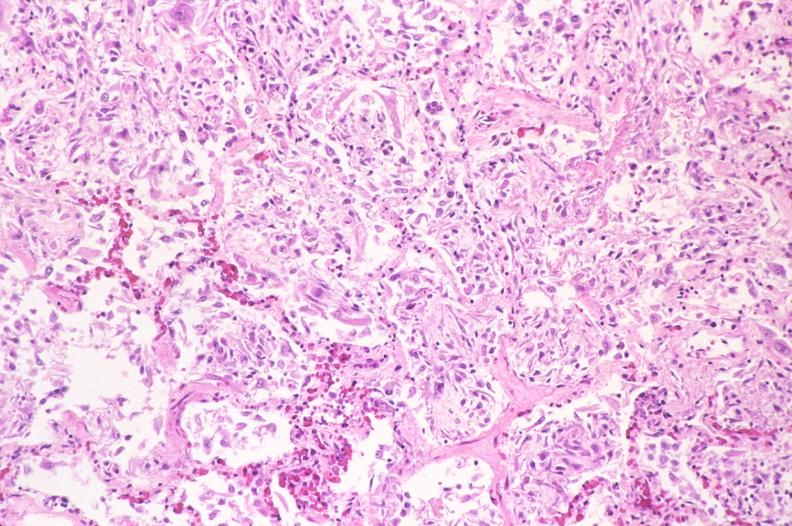what does this image show?
Answer the question using a single word or phrase. Lung 